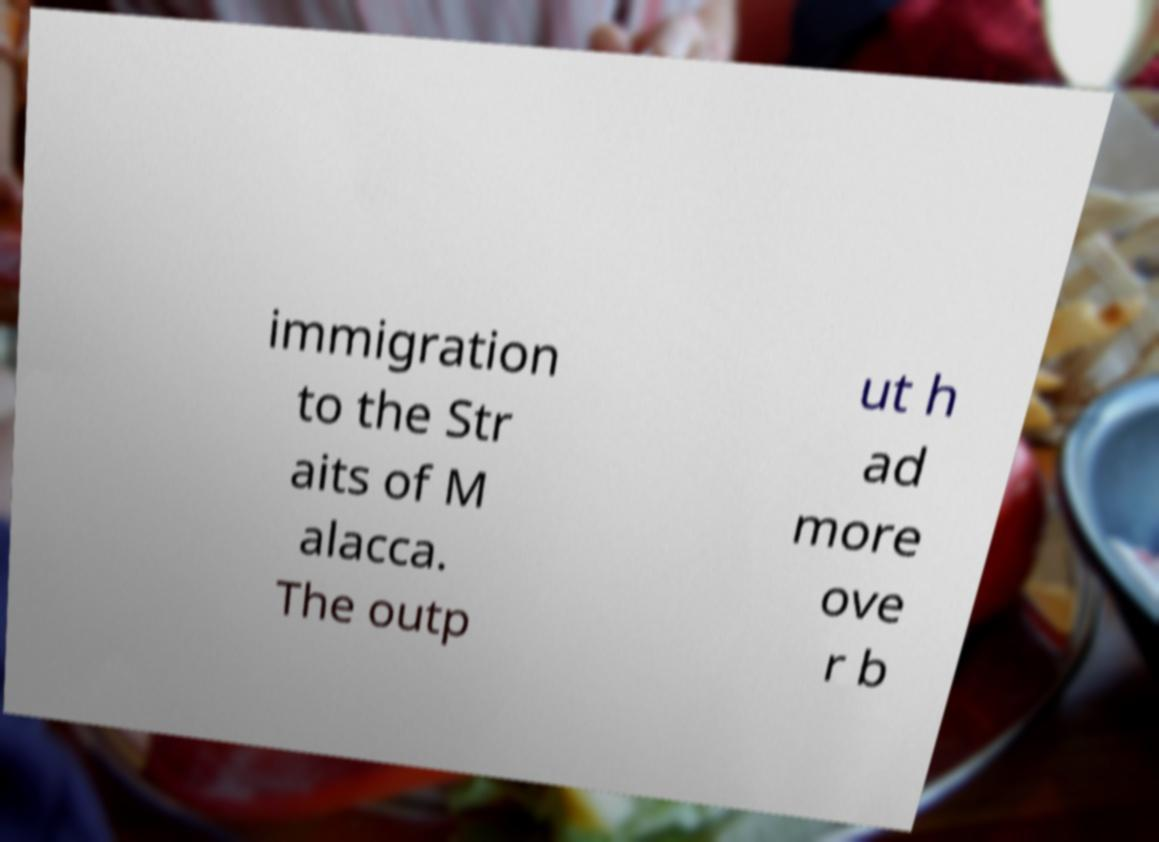What messages or text are displayed in this image? I need them in a readable, typed format. immigration to the Str aits of M alacca. The outp ut h ad more ove r b 